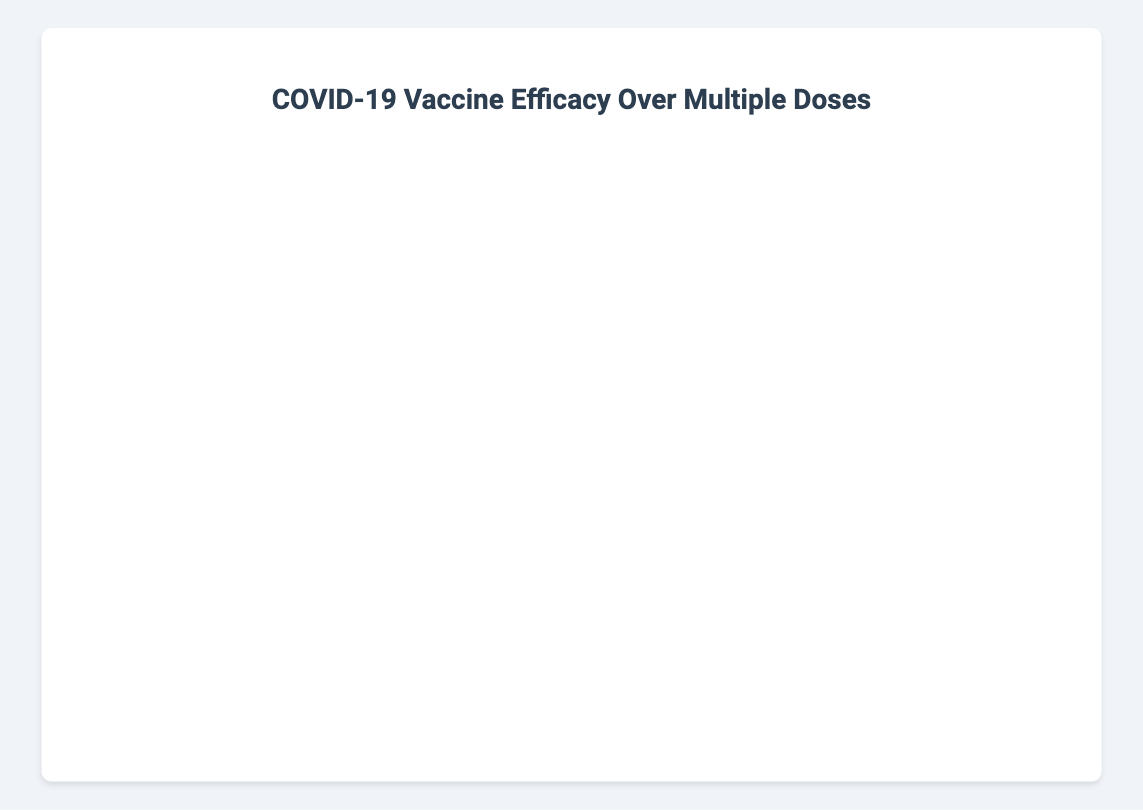Which vaccine shows the highest efficacy after three doses? Check all the data points for the third dose and identify the one with the highest efficacy percentage. USA's Pfizer-BioNTech shows 90%, UK's AstraZeneca shows 80%, Germany's Moderna shows 92%, Brazil's Sinovac shows 68%, and India's Covaxin shows 85%. The highest is Moderna at 92%.
Answer: Moderna How does the efficacy of Sinovac after two doses compare with Pfizer-BioNTech after two doses? Sinovac's efficacy after two doses is 62%, and Pfizer-BioNTech's efficacy after two doses is 95%. 95% is higher than 62%.
Answer: Pfizer-BioNTech has higher efficacy Which vaccine in the USA shows the greatest increase in efficacy from one dose to two doses? In the USA, Pfizer-BioNTech shows an increase from 52% to 95% when moving from one dose to two doses. The increase is 95% - 52% = 43%.
Answer: Pfizer-BioNTech What is the average efficacy of Covaxin across all three doses? Covaxin's efficacies are 78% (1 dose), 81% (2 doses), and 85% (3 doses). The average is (78 + 81 + 85) / 3 = 81.33%.
Answer: 81.33% Which country shows the lowest efficacy for a single dose, and what is the percentage? Look across all the vaccines for each country's single dose data. Brazil's Sinovac shows the lowest efficacy with 51%.
Answer: Brazil with 51% How does the efficacy trend for AstraZeneca change from dose one to dose three in the UK? AstraZeneca's efficacy in the UK is 70% (1 dose), 85% (2 doses), and 80% (3 doses). It increases from dose one to dose two by 15% and then slightly decreases from dose two to dose three by 5%.
Answer: Increases then slightly decreases What is the total efficacy increase for Moderna from one dose to three doses in Germany? Moderna's efficacy in Germany is 50% (1 dose), 94.1% (2 doses), and 92% (3 doses). The increase from one dose to two doses is 94.1% - 50% = 44.1%. The increase from two doses to three doses shows a small decrease, so the total increase is 92% - 50% = 42%.
Answer: 42% Compare the efficacy difference between the first and third doses for Covaxin and Sinovac. Which one had a greater efficacy increase? Covaxin's efficacy increase from the first dose (78%) to the third dose (85%) is 85% - 78% = 7%. Sinovac's efficacy increase from the first dose (51%) to the third dose (68%) is 68% - 51% = 17%. Sinovac shows a greater increase.
Answer: Sinovac Which vaccine has consistent results without any decrease in efficacy across doses? By examining the data, Covaxin shows a consistent increase in efficacy from 78% (1 dose) to 81% (2 doses) to 85% (3 doses), without any decrease across doses.
Answer: Covaxin 